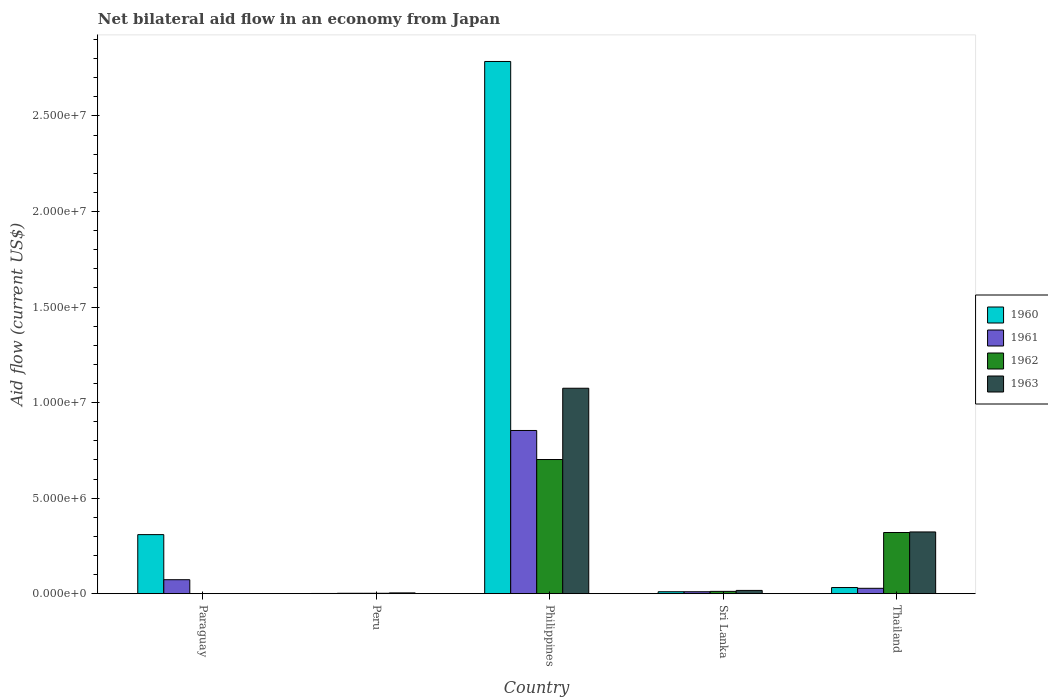How many different coloured bars are there?
Make the answer very short. 4. How many groups of bars are there?
Your response must be concise. 5. Are the number of bars on each tick of the X-axis equal?
Make the answer very short. No. How many bars are there on the 5th tick from the right?
Provide a succinct answer. 2. What is the label of the 1st group of bars from the left?
Provide a short and direct response. Paraguay. In how many cases, is the number of bars for a given country not equal to the number of legend labels?
Your response must be concise. 1. Across all countries, what is the maximum net bilateral aid flow in 1963?
Provide a succinct answer. 1.08e+07. In which country was the net bilateral aid flow in 1960 maximum?
Your answer should be compact. Philippines. What is the total net bilateral aid flow in 1961 in the graph?
Your response must be concise. 9.67e+06. What is the difference between the net bilateral aid flow in 1960 in Sri Lanka and that in Thailand?
Offer a very short reply. -2.20e+05. What is the difference between the net bilateral aid flow in 1963 in Paraguay and the net bilateral aid flow in 1961 in Sri Lanka?
Provide a succinct answer. -1.00e+05. What is the average net bilateral aid flow in 1962 per country?
Make the answer very short. 2.07e+06. What is the ratio of the net bilateral aid flow in 1962 in Sri Lanka to that in Thailand?
Your response must be concise. 0.04. Is the difference between the net bilateral aid flow in 1960 in Paraguay and Sri Lanka greater than the difference between the net bilateral aid flow in 1961 in Paraguay and Sri Lanka?
Provide a succinct answer. Yes. What is the difference between the highest and the second highest net bilateral aid flow in 1960?
Provide a succinct answer. 2.75e+07. What is the difference between the highest and the lowest net bilateral aid flow in 1962?
Provide a succinct answer. 7.02e+06. In how many countries, is the net bilateral aid flow in 1962 greater than the average net bilateral aid flow in 1962 taken over all countries?
Provide a succinct answer. 2. Is the sum of the net bilateral aid flow in 1961 in Sri Lanka and Thailand greater than the maximum net bilateral aid flow in 1960 across all countries?
Ensure brevity in your answer.  No. Is it the case that in every country, the sum of the net bilateral aid flow in 1961 and net bilateral aid flow in 1963 is greater than the sum of net bilateral aid flow in 1960 and net bilateral aid flow in 1962?
Your response must be concise. No. How many bars are there?
Offer a very short reply. 18. How many countries are there in the graph?
Your response must be concise. 5. What is the difference between two consecutive major ticks on the Y-axis?
Give a very brief answer. 5.00e+06. Does the graph contain any zero values?
Your answer should be very brief. Yes. Where does the legend appear in the graph?
Make the answer very short. Center right. How many legend labels are there?
Offer a terse response. 4. What is the title of the graph?
Give a very brief answer. Net bilateral aid flow in an economy from Japan. What is the label or title of the X-axis?
Your answer should be compact. Country. What is the Aid flow (current US$) in 1960 in Paraguay?
Offer a very short reply. 3.09e+06. What is the Aid flow (current US$) of 1961 in Paraguay?
Ensure brevity in your answer.  7.30e+05. What is the Aid flow (current US$) of 1960 in Peru?
Your response must be concise. 10000. What is the Aid flow (current US$) in 1963 in Peru?
Offer a terse response. 4.00e+04. What is the Aid flow (current US$) of 1960 in Philippines?
Offer a terse response. 2.78e+07. What is the Aid flow (current US$) of 1961 in Philippines?
Your response must be concise. 8.54e+06. What is the Aid flow (current US$) of 1962 in Philippines?
Keep it short and to the point. 7.02e+06. What is the Aid flow (current US$) of 1963 in Philippines?
Keep it short and to the point. 1.08e+07. What is the Aid flow (current US$) in 1961 in Sri Lanka?
Make the answer very short. 1.00e+05. What is the Aid flow (current US$) in 1962 in Sri Lanka?
Provide a short and direct response. 1.20e+05. What is the Aid flow (current US$) in 1960 in Thailand?
Provide a succinct answer. 3.20e+05. What is the Aid flow (current US$) in 1962 in Thailand?
Your answer should be compact. 3.20e+06. What is the Aid flow (current US$) in 1963 in Thailand?
Keep it short and to the point. 3.23e+06. Across all countries, what is the maximum Aid flow (current US$) in 1960?
Offer a very short reply. 2.78e+07. Across all countries, what is the maximum Aid flow (current US$) of 1961?
Your answer should be very brief. 8.54e+06. Across all countries, what is the maximum Aid flow (current US$) in 1962?
Make the answer very short. 7.02e+06. Across all countries, what is the maximum Aid flow (current US$) of 1963?
Give a very brief answer. 1.08e+07. Across all countries, what is the minimum Aid flow (current US$) of 1961?
Ensure brevity in your answer.  2.00e+04. Across all countries, what is the minimum Aid flow (current US$) in 1962?
Provide a short and direct response. 0. Across all countries, what is the minimum Aid flow (current US$) of 1963?
Ensure brevity in your answer.  0. What is the total Aid flow (current US$) in 1960 in the graph?
Offer a very short reply. 3.14e+07. What is the total Aid flow (current US$) of 1961 in the graph?
Keep it short and to the point. 9.67e+06. What is the total Aid flow (current US$) in 1962 in the graph?
Ensure brevity in your answer.  1.04e+07. What is the total Aid flow (current US$) in 1963 in the graph?
Offer a terse response. 1.42e+07. What is the difference between the Aid flow (current US$) of 1960 in Paraguay and that in Peru?
Give a very brief answer. 3.08e+06. What is the difference between the Aid flow (current US$) in 1961 in Paraguay and that in Peru?
Ensure brevity in your answer.  7.10e+05. What is the difference between the Aid flow (current US$) of 1960 in Paraguay and that in Philippines?
Offer a very short reply. -2.48e+07. What is the difference between the Aid flow (current US$) of 1961 in Paraguay and that in Philippines?
Keep it short and to the point. -7.81e+06. What is the difference between the Aid flow (current US$) of 1960 in Paraguay and that in Sri Lanka?
Keep it short and to the point. 2.99e+06. What is the difference between the Aid flow (current US$) in 1961 in Paraguay and that in Sri Lanka?
Offer a terse response. 6.30e+05. What is the difference between the Aid flow (current US$) in 1960 in Paraguay and that in Thailand?
Ensure brevity in your answer.  2.77e+06. What is the difference between the Aid flow (current US$) in 1961 in Paraguay and that in Thailand?
Your answer should be very brief. 4.50e+05. What is the difference between the Aid flow (current US$) in 1960 in Peru and that in Philippines?
Give a very brief answer. -2.78e+07. What is the difference between the Aid flow (current US$) of 1961 in Peru and that in Philippines?
Give a very brief answer. -8.52e+06. What is the difference between the Aid flow (current US$) of 1962 in Peru and that in Philippines?
Keep it short and to the point. -7.00e+06. What is the difference between the Aid flow (current US$) of 1963 in Peru and that in Philippines?
Keep it short and to the point. -1.07e+07. What is the difference between the Aid flow (current US$) in 1960 in Peru and that in Sri Lanka?
Offer a very short reply. -9.00e+04. What is the difference between the Aid flow (current US$) in 1961 in Peru and that in Sri Lanka?
Provide a short and direct response. -8.00e+04. What is the difference between the Aid flow (current US$) of 1960 in Peru and that in Thailand?
Give a very brief answer. -3.10e+05. What is the difference between the Aid flow (current US$) in 1962 in Peru and that in Thailand?
Provide a succinct answer. -3.18e+06. What is the difference between the Aid flow (current US$) in 1963 in Peru and that in Thailand?
Ensure brevity in your answer.  -3.19e+06. What is the difference between the Aid flow (current US$) of 1960 in Philippines and that in Sri Lanka?
Make the answer very short. 2.78e+07. What is the difference between the Aid flow (current US$) of 1961 in Philippines and that in Sri Lanka?
Make the answer very short. 8.44e+06. What is the difference between the Aid flow (current US$) of 1962 in Philippines and that in Sri Lanka?
Your answer should be very brief. 6.90e+06. What is the difference between the Aid flow (current US$) of 1963 in Philippines and that in Sri Lanka?
Keep it short and to the point. 1.06e+07. What is the difference between the Aid flow (current US$) in 1960 in Philippines and that in Thailand?
Keep it short and to the point. 2.75e+07. What is the difference between the Aid flow (current US$) of 1961 in Philippines and that in Thailand?
Offer a terse response. 8.26e+06. What is the difference between the Aid flow (current US$) of 1962 in Philippines and that in Thailand?
Keep it short and to the point. 3.82e+06. What is the difference between the Aid flow (current US$) in 1963 in Philippines and that in Thailand?
Ensure brevity in your answer.  7.52e+06. What is the difference between the Aid flow (current US$) in 1960 in Sri Lanka and that in Thailand?
Offer a very short reply. -2.20e+05. What is the difference between the Aid flow (current US$) in 1961 in Sri Lanka and that in Thailand?
Give a very brief answer. -1.80e+05. What is the difference between the Aid flow (current US$) of 1962 in Sri Lanka and that in Thailand?
Your response must be concise. -3.08e+06. What is the difference between the Aid flow (current US$) in 1963 in Sri Lanka and that in Thailand?
Provide a short and direct response. -3.06e+06. What is the difference between the Aid flow (current US$) in 1960 in Paraguay and the Aid flow (current US$) in 1961 in Peru?
Ensure brevity in your answer.  3.07e+06. What is the difference between the Aid flow (current US$) of 1960 in Paraguay and the Aid flow (current US$) of 1962 in Peru?
Make the answer very short. 3.07e+06. What is the difference between the Aid flow (current US$) in 1960 in Paraguay and the Aid flow (current US$) in 1963 in Peru?
Provide a short and direct response. 3.05e+06. What is the difference between the Aid flow (current US$) of 1961 in Paraguay and the Aid flow (current US$) of 1962 in Peru?
Offer a terse response. 7.10e+05. What is the difference between the Aid flow (current US$) of 1961 in Paraguay and the Aid flow (current US$) of 1963 in Peru?
Your response must be concise. 6.90e+05. What is the difference between the Aid flow (current US$) in 1960 in Paraguay and the Aid flow (current US$) in 1961 in Philippines?
Your answer should be very brief. -5.45e+06. What is the difference between the Aid flow (current US$) of 1960 in Paraguay and the Aid flow (current US$) of 1962 in Philippines?
Provide a short and direct response. -3.93e+06. What is the difference between the Aid flow (current US$) of 1960 in Paraguay and the Aid flow (current US$) of 1963 in Philippines?
Provide a succinct answer. -7.66e+06. What is the difference between the Aid flow (current US$) in 1961 in Paraguay and the Aid flow (current US$) in 1962 in Philippines?
Offer a terse response. -6.29e+06. What is the difference between the Aid flow (current US$) in 1961 in Paraguay and the Aid flow (current US$) in 1963 in Philippines?
Provide a short and direct response. -1.00e+07. What is the difference between the Aid flow (current US$) in 1960 in Paraguay and the Aid flow (current US$) in 1961 in Sri Lanka?
Offer a terse response. 2.99e+06. What is the difference between the Aid flow (current US$) in 1960 in Paraguay and the Aid flow (current US$) in 1962 in Sri Lanka?
Provide a short and direct response. 2.97e+06. What is the difference between the Aid flow (current US$) in 1960 in Paraguay and the Aid flow (current US$) in 1963 in Sri Lanka?
Offer a terse response. 2.92e+06. What is the difference between the Aid flow (current US$) in 1961 in Paraguay and the Aid flow (current US$) in 1962 in Sri Lanka?
Give a very brief answer. 6.10e+05. What is the difference between the Aid flow (current US$) of 1961 in Paraguay and the Aid flow (current US$) of 1963 in Sri Lanka?
Ensure brevity in your answer.  5.60e+05. What is the difference between the Aid flow (current US$) of 1960 in Paraguay and the Aid flow (current US$) of 1961 in Thailand?
Offer a terse response. 2.81e+06. What is the difference between the Aid flow (current US$) in 1960 in Paraguay and the Aid flow (current US$) in 1962 in Thailand?
Offer a terse response. -1.10e+05. What is the difference between the Aid flow (current US$) of 1960 in Paraguay and the Aid flow (current US$) of 1963 in Thailand?
Offer a terse response. -1.40e+05. What is the difference between the Aid flow (current US$) in 1961 in Paraguay and the Aid flow (current US$) in 1962 in Thailand?
Ensure brevity in your answer.  -2.47e+06. What is the difference between the Aid flow (current US$) of 1961 in Paraguay and the Aid flow (current US$) of 1963 in Thailand?
Give a very brief answer. -2.50e+06. What is the difference between the Aid flow (current US$) in 1960 in Peru and the Aid flow (current US$) in 1961 in Philippines?
Give a very brief answer. -8.53e+06. What is the difference between the Aid flow (current US$) of 1960 in Peru and the Aid flow (current US$) of 1962 in Philippines?
Offer a terse response. -7.01e+06. What is the difference between the Aid flow (current US$) of 1960 in Peru and the Aid flow (current US$) of 1963 in Philippines?
Your answer should be compact. -1.07e+07. What is the difference between the Aid flow (current US$) in 1961 in Peru and the Aid flow (current US$) in 1962 in Philippines?
Provide a succinct answer. -7.00e+06. What is the difference between the Aid flow (current US$) of 1961 in Peru and the Aid flow (current US$) of 1963 in Philippines?
Offer a very short reply. -1.07e+07. What is the difference between the Aid flow (current US$) in 1962 in Peru and the Aid flow (current US$) in 1963 in Philippines?
Ensure brevity in your answer.  -1.07e+07. What is the difference between the Aid flow (current US$) of 1960 in Peru and the Aid flow (current US$) of 1962 in Sri Lanka?
Offer a terse response. -1.10e+05. What is the difference between the Aid flow (current US$) of 1960 in Peru and the Aid flow (current US$) of 1963 in Sri Lanka?
Provide a short and direct response. -1.60e+05. What is the difference between the Aid flow (current US$) in 1961 in Peru and the Aid flow (current US$) in 1962 in Sri Lanka?
Your response must be concise. -1.00e+05. What is the difference between the Aid flow (current US$) of 1962 in Peru and the Aid flow (current US$) of 1963 in Sri Lanka?
Offer a very short reply. -1.50e+05. What is the difference between the Aid flow (current US$) of 1960 in Peru and the Aid flow (current US$) of 1962 in Thailand?
Your answer should be very brief. -3.19e+06. What is the difference between the Aid flow (current US$) in 1960 in Peru and the Aid flow (current US$) in 1963 in Thailand?
Offer a terse response. -3.22e+06. What is the difference between the Aid flow (current US$) of 1961 in Peru and the Aid flow (current US$) of 1962 in Thailand?
Offer a terse response. -3.18e+06. What is the difference between the Aid flow (current US$) of 1961 in Peru and the Aid flow (current US$) of 1963 in Thailand?
Ensure brevity in your answer.  -3.21e+06. What is the difference between the Aid flow (current US$) in 1962 in Peru and the Aid flow (current US$) in 1963 in Thailand?
Keep it short and to the point. -3.21e+06. What is the difference between the Aid flow (current US$) of 1960 in Philippines and the Aid flow (current US$) of 1961 in Sri Lanka?
Give a very brief answer. 2.78e+07. What is the difference between the Aid flow (current US$) in 1960 in Philippines and the Aid flow (current US$) in 1962 in Sri Lanka?
Keep it short and to the point. 2.77e+07. What is the difference between the Aid flow (current US$) in 1960 in Philippines and the Aid flow (current US$) in 1963 in Sri Lanka?
Provide a succinct answer. 2.77e+07. What is the difference between the Aid flow (current US$) of 1961 in Philippines and the Aid flow (current US$) of 1962 in Sri Lanka?
Your answer should be compact. 8.42e+06. What is the difference between the Aid flow (current US$) of 1961 in Philippines and the Aid flow (current US$) of 1963 in Sri Lanka?
Your answer should be compact. 8.37e+06. What is the difference between the Aid flow (current US$) of 1962 in Philippines and the Aid flow (current US$) of 1963 in Sri Lanka?
Provide a short and direct response. 6.85e+06. What is the difference between the Aid flow (current US$) in 1960 in Philippines and the Aid flow (current US$) in 1961 in Thailand?
Give a very brief answer. 2.76e+07. What is the difference between the Aid flow (current US$) of 1960 in Philippines and the Aid flow (current US$) of 1962 in Thailand?
Provide a succinct answer. 2.46e+07. What is the difference between the Aid flow (current US$) in 1960 in Philippines and the Aid flow (current US$) in 1963 in Thailand?
Offer a terse response. 2.46e+07. What is the difference between the Aid flow (current US$) of 1961 in Philippines and the Aid flow (current US$) of 1962 in Thailand?
Keep it short and to the point. 5.34e+06. What is the difference between the Aid flow (current US$) of 1961 in Philippines and the Aid flow (current US$) of 1963 in Thailand?
Ensure brevity in your answer.  5.31e+06. What is the difference between the Aid flow (current US$) in 1962 in Philippines and the Aid flow (current US$) in 1963 in Thailand?
Your answer should be very brief. 3.79e+06. What is the difference between the Aid flow (current US$) in 1960 in Sri Lanka and the Aid flow (current US$) in 1961 in Thailand?
Give a very brief answer. -1.80e+05. What is the difference between the Aid flow (current US$) in 1960 in Sri Lanka and the Aid flow (current US$) in 1962 in Thailand?
Your answer should be very brief. -3.10e+06. What is the difference between the Aid flow (current US$) of 1960 in Sri Lanka and the Aid flow (current US$) of 1963 in Thailand?
Your response must be concise. -3.13e+06. What is the difference between the Aid flow (current US$) in 1961 in Sri Lanka and the Aid flow (current US$) in 1962 in Thailand?
Your answer should be compact. -3.10e+06. What is the difference between the Aid flow (current US$) in 1961 in Sri Lanka and the Aid flow (current US$) in 1963 in Thailand?
Your answer should be compact. -3.13e+06. What is the difference between the Aid flow (current US$) in 1962 in Sri Lanka and the Aid flow (current US$) in 1963 in Thailand?
Ensure brevity in your answer.  -3.11e+06. What is the average Aid flow (current US$) of 1960 per country?
Make the answer very short. 6.27e+06. What is the average Aid flow (current US$) of 1961 per country?
Offer a terse response. 1.93e+06. What is the average Aid flow (current US$) of 1962 per country?
Your answer should be compact. 2.07e+06. What is the average Aid flow (current US$) in 1963 per country?
Your response must be concise. 2.84e+06. What is the difference between the Aid flow (current US$) in 1960 and Aid flow (current US$) in 1961 in Paraguay?
Provide a succinct answer. 2.36e+06. What is the difference between the Aid flow (current US$) in 1960 and Aid flow (current US$) in 1961 in Peru?
Keep it short and to the point. -10000. What is the difference between the Aid flow (current US$) in 1961 and Aid flow (current US$) in 1963 in Peru?
Ensure brevity in your answer.  -2.00e+04. What is the difference between the Aid flow (current US$) in 1960 and Aid flow (current US$) in 1961 in Philippines?
Your response must be concise. 1.93e+07. What is the difference between the Aid flow (current US$) in 1960 and Aid flow (current US$) in 1962 in Philippines?
Your answer should be very brief. 2.08e+07. What is the difference between the Aid flow (current US$) of 1960 and Aid flow (current US$) of 1963 in Philippines?
Give a very brief answer. 1.71e+07. What is the difference between the Aid flow (current US$) of 1961 and Aid flow (current US$) of 1962 in Philippines?
Offer a very short reply. 1.52e+06. What is the difference between the Aid flow (current US$) in 1961 and Aid flow (current US$) in 1963 in Philippines?
Provide a succinct answer. -2.21e+06. What is the difference between the Aid flow (current US$) of 1962 and Aid flow (current US$) of 1963 in Philippines?
Your answer should be very brief. -3.73e+06. What is the difference between the Aid flow (current US$) of 1960 and Aid flow (current US$) of 1961 in Sri Lanka?
Offer a terse response. 0. What is the difference between the Aid flow (current US$) in 1962 and Aid flow (current US$) in 1963 in Sri Lanka?
Your answer should be compact. -5.00e+04. What is the difference between the Aid flow (current US$) of 1960 and Aid flow (current US$) of 1962 in Thailand?
Provide a succinct answer. -2.88e+06. What is the difference between the Aid flow (current US$) of 1960 and Aid flow (current US$) of 1963 in Thailand?
Keep it short and to the point. -2.91e+06. What is the difference between the Aid flow (current US$) of 1961 and Aid flow (current US$) of 1962 in Thailand?
Ensure brevity in your answer.  -2.92e+06. What is the difference between the Aid flow (current US$) of 1961 and Aid flow (current US$) of 1963 in Thailand?
Your answer should be very brief. -2.95e+06. What is the difference between the Aid flow (current US$) of 1962 and Aid flow (current US$) of 1963 in Thailand?
Make the answer very short. -3.00e+04. What is the ratio of the Aid flow (current US$) of 1960 in Paraguay to that in Peru?
Ensure brevity in your answer.  309. What is the ratio of the Aid flow (current US$) of 1961 in Paraguay to that in Peru?
Provide a short and direct response. 36.5. What is the ratio of the Aid flow (current US$) of 1960 in Paraguay to that in Philippines?
Offer a terse response. 0.11. What is the ratio of the Aid flow (current US$) in 1961 in Paraguay to that in Philippines?
Keep it short and to the point. 0.09. What is the ratio of the Aid flow (current US$) in 1960 in Paraguay to that in Sri Lanka?
Ensure brevity in your answer.  30.9. What is the ratio of the Aid flow (current US$) in 1960 in Paraguay to that in Thailand?
Your response must be concise. 9.66. What is the ratio of the Aid flow (current US$) in 1961 in Paraguay to that in Thailand?
Your answer should be compact. 2.61. What is the ratio of the Aid flow (current US$) in 1961 in Peru to that in Philippines?
Provide a succinct answer. 0. What is the ratio of the Aid flow (current US$) in 1962 in Peru to that in Philippines?
Keep it short and to the point. 0. What is the ratio of the Aid flow (current US$) of 1963 in Peru to that in Philippines?
Your answer should be compact. 0. What is the ratio of the Aid flow (current US$) in 1960 in Peru to that in Sri Lanka?
Offer a very short reply. 0.1. What is the ratio of the Aid flow (current US$) in 1961 in Peru to that in Sri Lanka?
Offer a terse response. 0.2. What is the ratio of the Aid flow (current US$) of 1962 in Peru to that in Sri Lanka?
Your answer should be very brief. 0.17. What is the ratio of the Aid flow (current US$) of 1963 in Peru to that in Sri Lanka?
Provide a short and direct response. 0.24. What is the ratio of the Aid flow (current US$) of 1960 in Peru to that in Thailand?
Ensure brevity in your answer.  0.03. What is the ratio of the Aid flow (current US$) in 1961 in Peru to that in Thailand?
Offer a terse response. 0.07. What is the ratio of the Aid flow (current US$) in 1962 in Peru to that in Thailand?
Your answer should be compact. 0.01. What is the ratio of the Aid flow (current US$) of 1963 in Peru to that in Thailand?
Keep it short and to the point. 0.01. What is the ratio of the Aid flow (current US$) in 1960 in Philippines to that in Sri Lanka?
Your response must be concise. 278.5. What is the ratio of the Aid flow (current US$) in 1961 in Philippines to that in Sri Lanka?
Offer a very short reply. 85.4. What is the ratio of the Aid flow (current US$) in 1962 in Philippines to that in Sri Lanka?
Give a very brief answer. 58.5. What is the ratio of the Aid flow (current US$) in 1963 in Philippines to that in Sri Lanka?
Provide a short and direct response. 63.24. What is the ratio of the Aid flow (current US$) in 1960 in Philippines to that in Thailand?
Your response must be concise. 87.03. What is the ratio of the Aid flow (current US$) in 1961 in Philippines to that in Thailand?
Offer a very short reply. 30.5. What is the ratio of the Aid flow (current US$) in 1962 in Philippines to that in Thailand?
Your answer should be very brief. 2.19. What is the ratio of the Aid flow (current US$) of 1963 in Philippines to that in Thailand?
Offer a terse response. 3.33. What is the ratio of the Aid flow (current US$) of 1960 in Sri Lanka to that in Thailand?
Provide a succinct answer. 0.31. What is the ratio of the Aid flow (current US$) in 1961 in Sri Lanka to that in Thailand?
Your answer should be very brief. 0.36. What is the ratio of the Aid flow (current US$) of 1962 in Sri Lanka to that in Thailand?
Your answer should be very brief. 0.04. What is the ratio of the Aid flow (current US$) of 1963 in Sri Lanka to that in Thailand?
Make the answer very short. 0.05. What is the difference between the highest and the second highest Aid flow (current US$) in 1960?
Offer a terse response. 2.48e+07. What is the difference between the highest and the second highest Aid flow (current US$) in 1961?
Make the answer very short. 7.81e+06. What is the difference between the highest and the second highest Aid flow (current US$) in 1962?
Your response must be concise. 3.82e+06. What is the difference between the highest and the second highest Aid flow (current US$) in 1963?
Ensure brevity in your answer.  7.52e+06. What is the difference between the highest and the lowest Aid flow (current US$) in 1960?
Ensure brevity in your answer.  2.78e+07. What is the difference between the highest and the lowest Aid flow (current US$) of 1961?
Your response must be concise. 8.52e+06. What is the difference between the highest and the lowest Aid flow (current US$) of 1962?
Provide a succinct answer. 7.02e+06. What is the difference between the highest and the lowest Aid flow (current US$) of 1963?
Keep it short and to the point. 1.08e+07. 